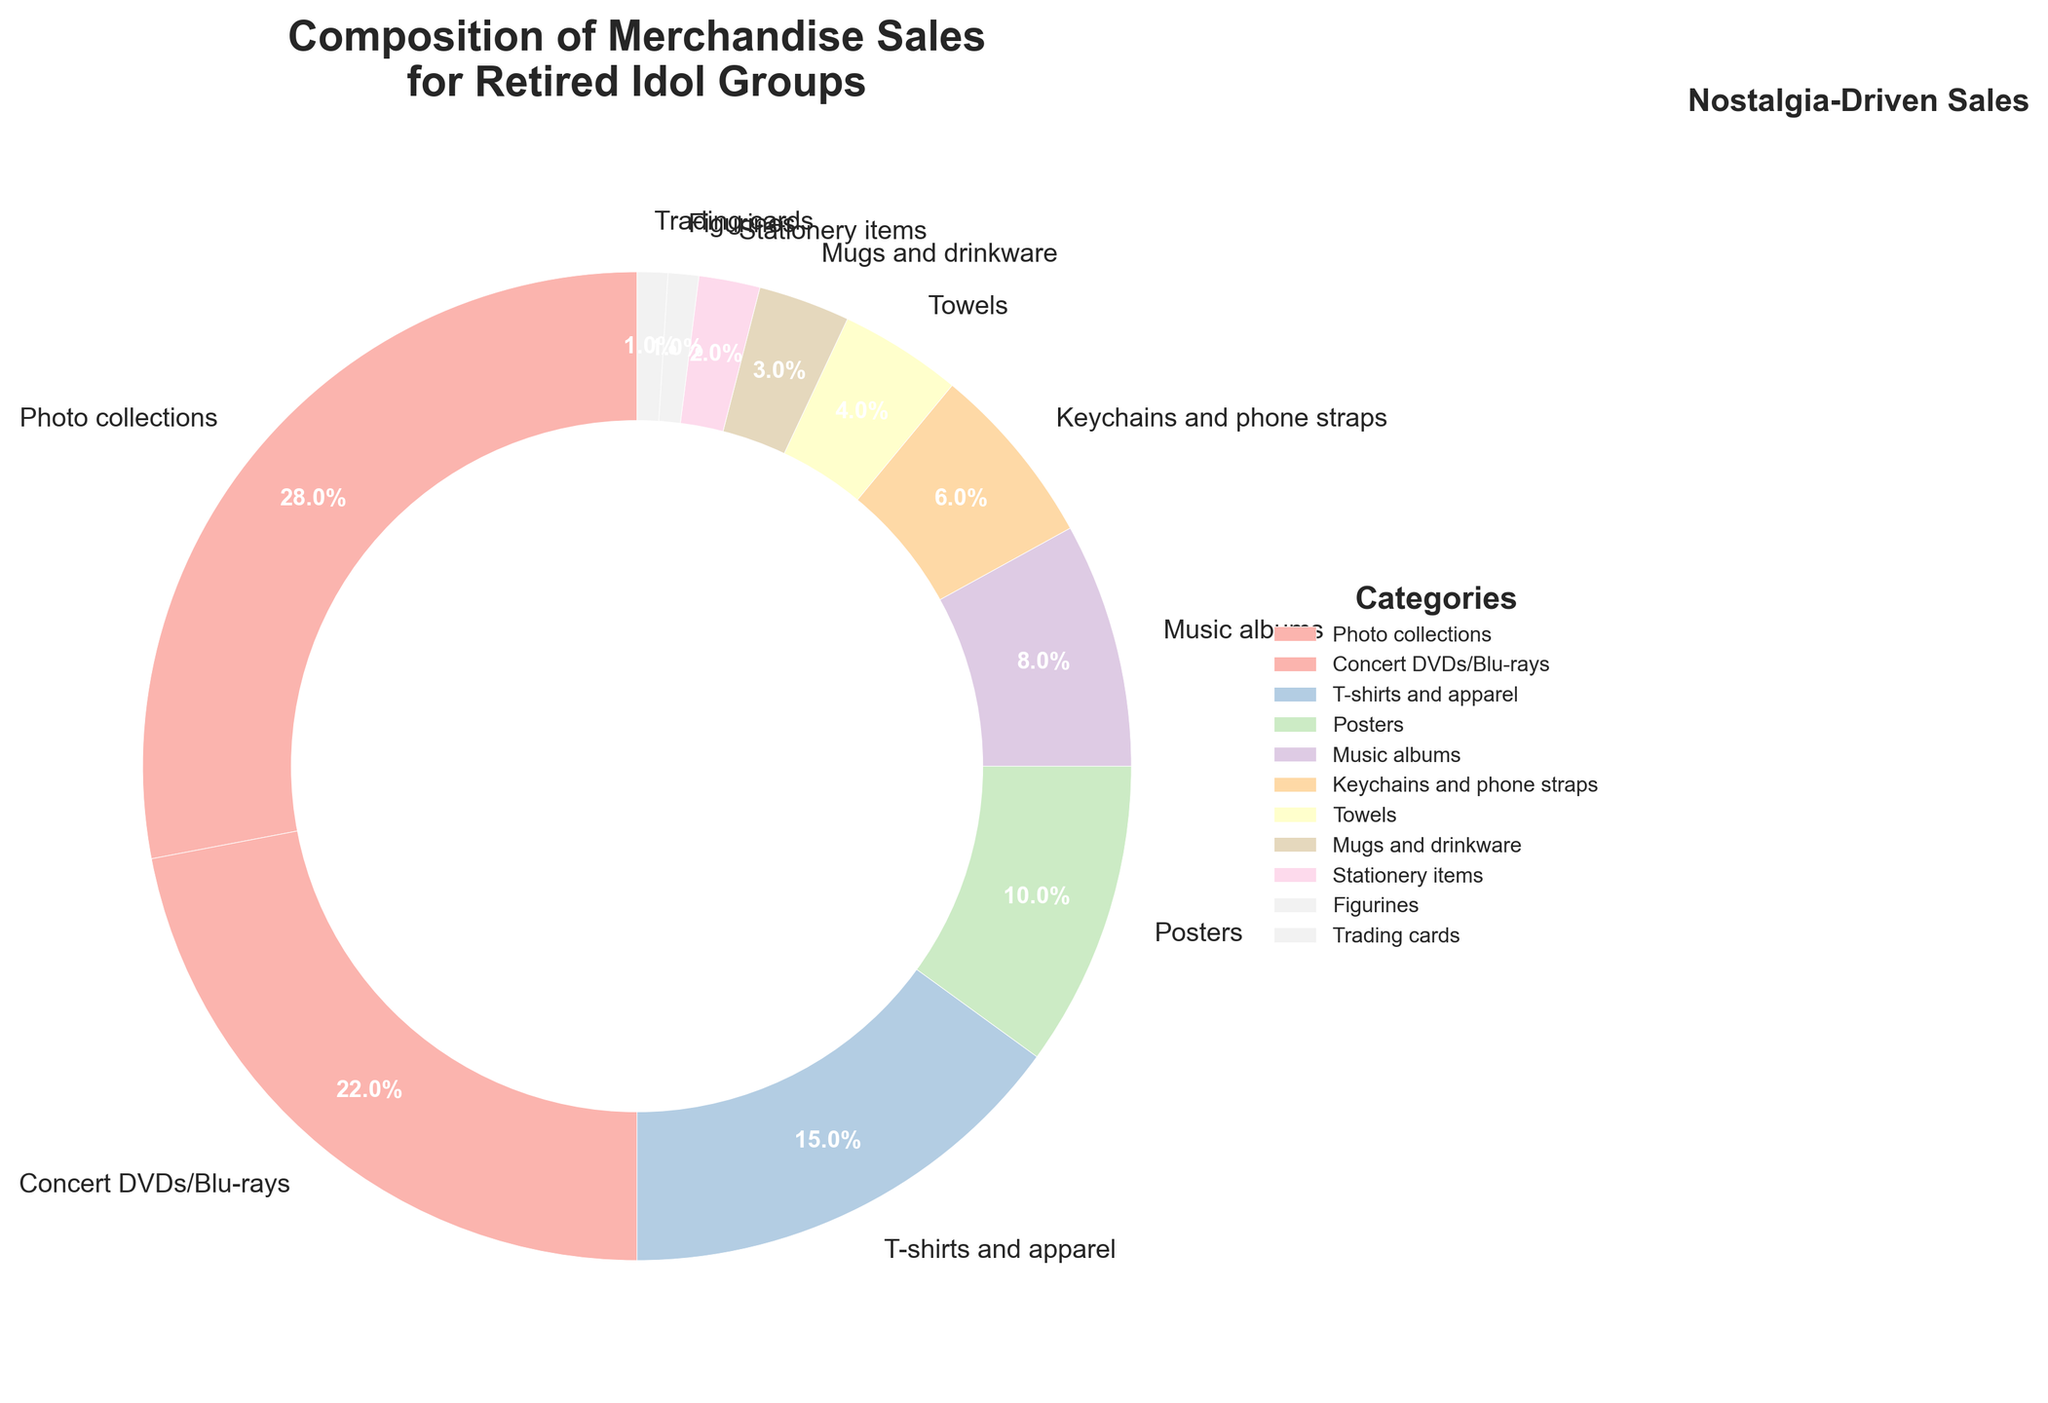Which category has the highest percentage of merchandise sales? The category with the largest segment in the pie chart is Photo collections. By visually inspecting the chart, we can see that this category is the largest, occupying 28% of the total.
Answer: Photo collections What is the combined percentage of T-shirts and apparel, Posters, and Keychains and phone straps? Sum the percentages of T-shirts and apparel (15%), Posters (10%), and Keychains and phone straps (6%): 15% + 10% + 6% = 31%.
Answer: 31% Is the percentage of Concert DVDs/Blu-rays larger or smaller than that of Music albums? By looking at the chart, Concert DVDs/Blu-rays constitute 22%, whereas Music albums are 8%. Therefore, Concert DVDs/Blu-rays have a larger percentage.
Answer: Larger How much greater is the percentage of Photo collections compared to Music albums? Subtract the percentage of Music albums (8%) from Photo collections (28%): 28% - 8% = 20%.
Answer: 20% Which category has a smaller percentage, Towels or Mugs and drinkware? Comparing the two segments, Towels have 4% whereas Mugs and drinkware have 3%. Therefore, Mugs and drinkware have a smaller percentage.
Answer: Mugs and drinkware What is the percentage range of the top three categories? The top three categories are identified as Photo collections (28%), Concert DVDs/Blu-rays (22%), and T-shirts and apparel (15%). The range between the highest (28%) and the lowest (15%) is 28% - 15% = 13%.
Answer: 13% If we group all items with less than or equal to 5% into a single category, what would their combined percentage be? Identify and sum the percentages of Keychains and phone straps (6%), Towels (4%), Mugs and drinkware (3%), Stationery items (2%), Figurines (1%), and Trading cards (1%): 4% + 3% + 2% + 1% + 1% = 11%. Therefore, their combined percentage is 11%.
Answer: 11% What visual attribute helps us know that the center circle is used to enhance visual appeal? The center circle is white, creating a donut chart effect. This visual attribute emphasizes the categorization by surrounding empty space, improving focus on the categorized percentages.
Answer: White circle Which category appears in a more prominent color, Music albums or Trading cards? By visually inspecting the pie chart, Music albums is assigned a more visually prominent color compared to Trading cards, helping it stand out more.
Answer: Music albums If you combine the percentages of Posters and Mugs and drinkware, does their total surpass that of T-shirts and apparel? Sum the percentages of Posters (10%) and Mugs and drinkware (3%): 10% + 3% = 13%. T-shirts and apparel have 15%. Since 13% is less than 15%, the combined total does not surpass that of T-shirts and apparel.
Answer: No 